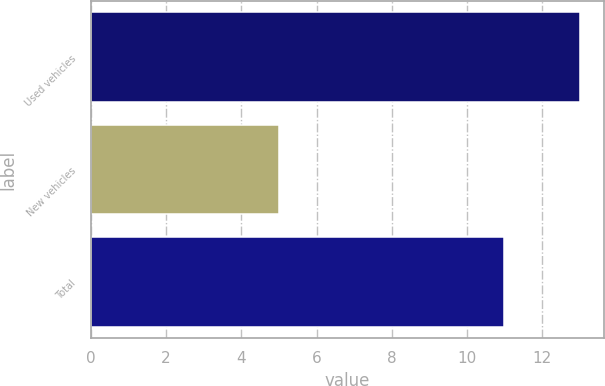<chart> <loc_0><loc_0><loc_500><loc_500><bar_chart><fcel>Used vehicles<fcel>New vehicles<fcel>Total<nl><fcel>13<fcel>5<fcel>11<nl></chart> 